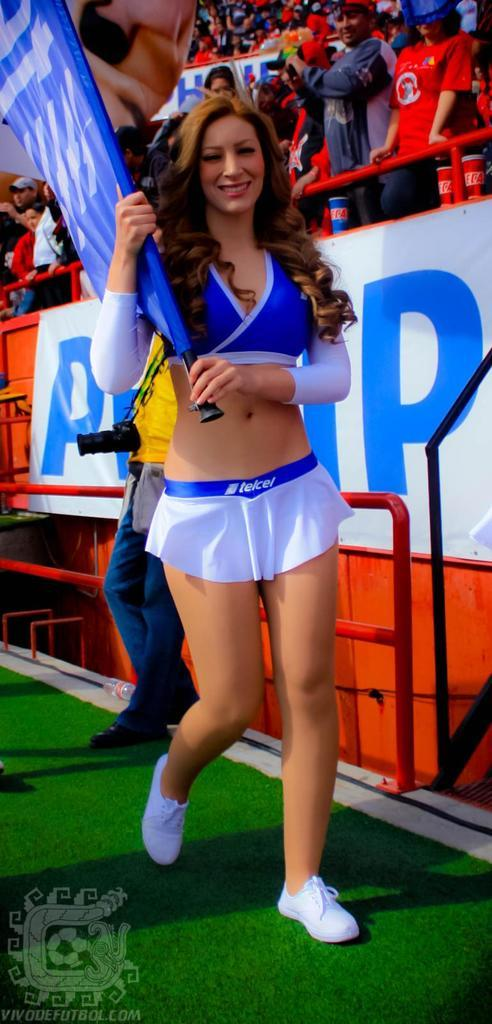<image>
Give a short and clear explanation of the subsequent image. A cheerleader is holding a flag at a sports game and her skirt says telcel. 